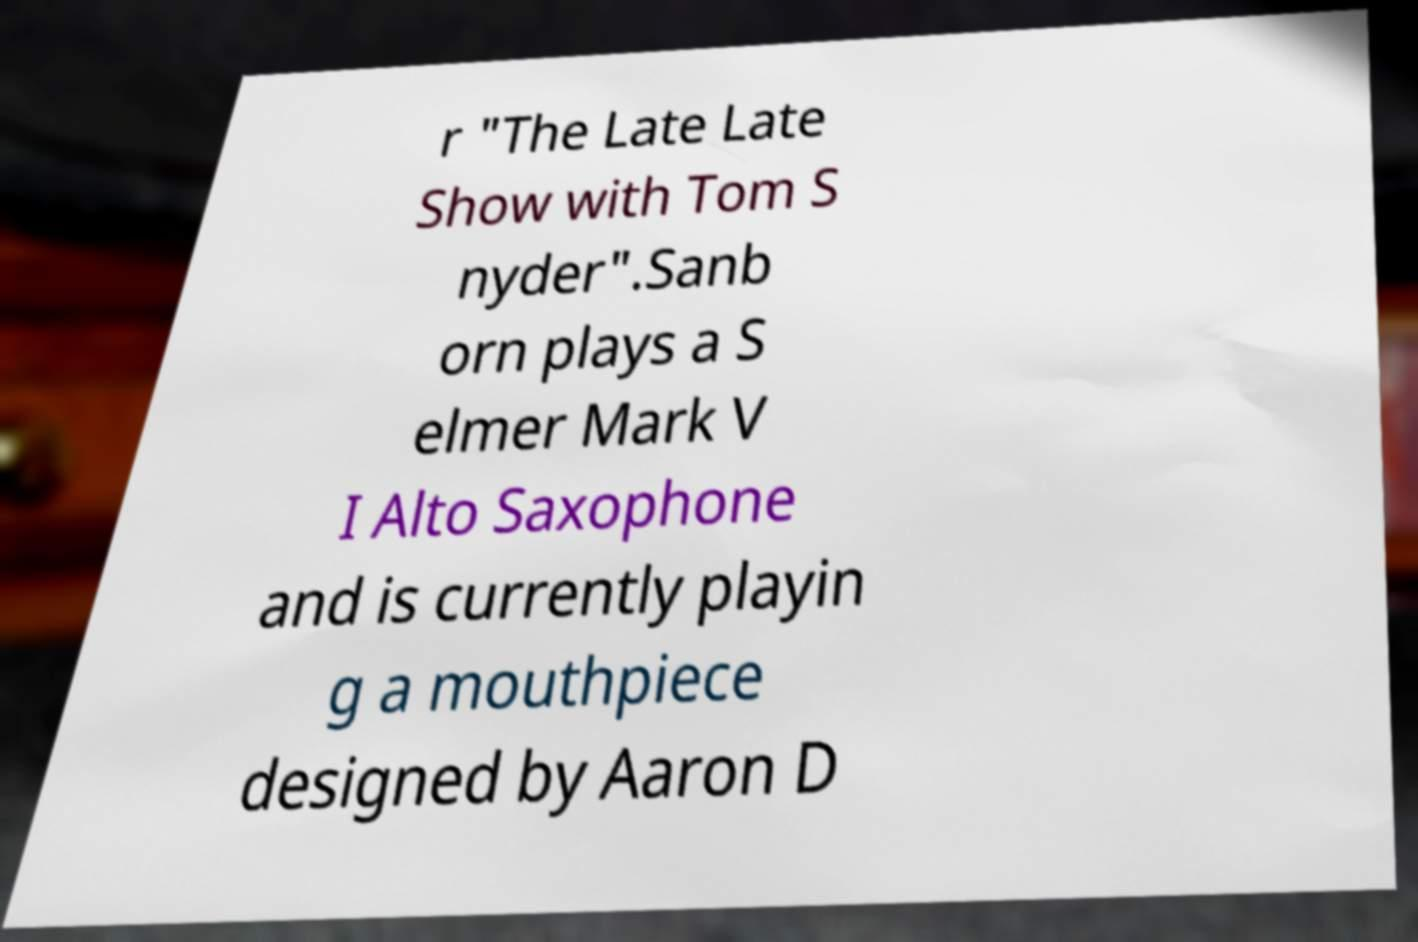Could you extract and type out the text from this image? r "The Late Late Show with Tom S nyder".Sanb orn plays a S elmer Mark V I Alto Saxophone and is currently playin g a mouthpiece designed by Aaron D 